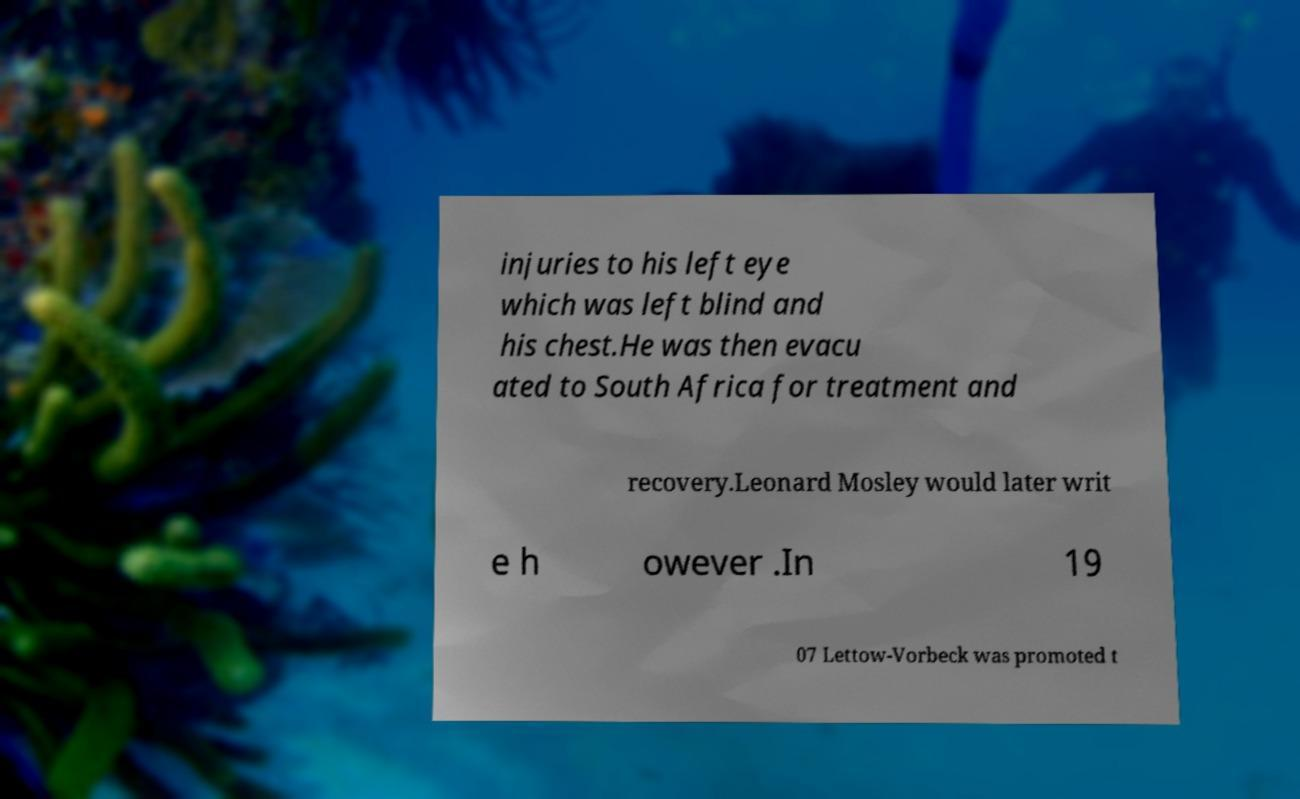Could you extract and type out the text from this image? injuries to his left eye which was left blind and his chest.He was then evacu ated to South Africa for treatment and recovery.Leonard Mosley would later writ e h owever .In 19 07 Lettow-Vorbeck was promoted t 